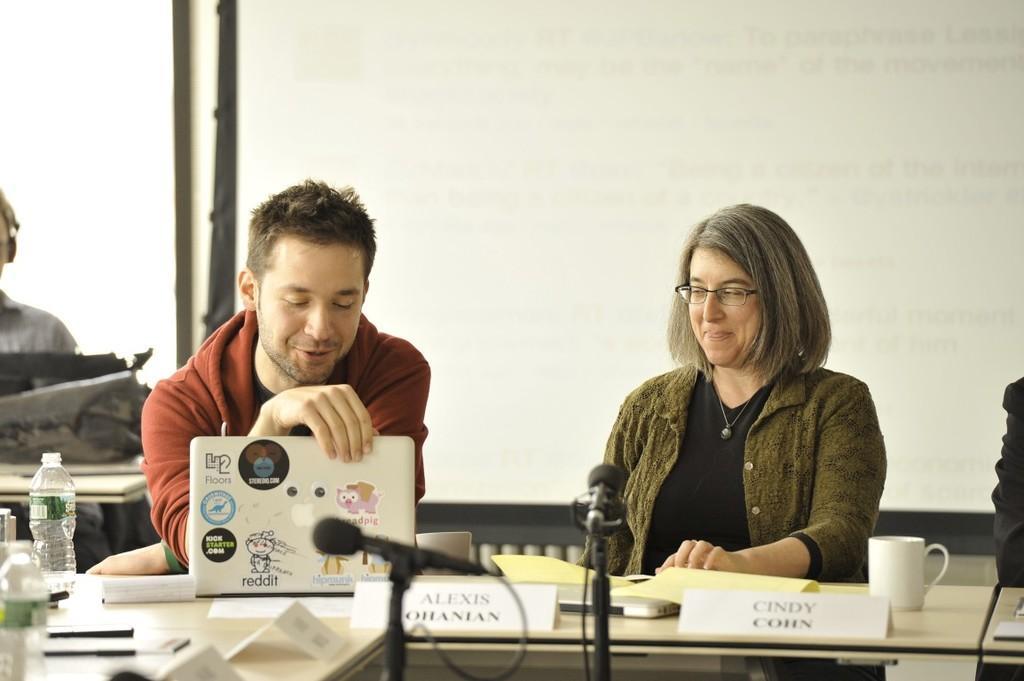Could you give a brief overview of what you see in this image? In this aimeg, we can see a woman and man are sitting and smiling. Here a person is holding a laptop. At the bottom, we can see tables. Few objects are placed on it. Background we can see the screen. On the left side, it seems like a person is sitting. Here we can see few objects and wall. 